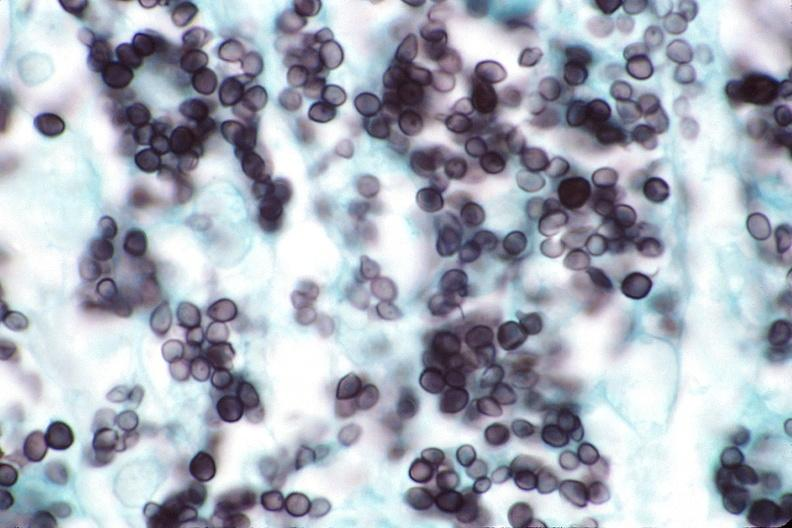what is present?
Answer the question using a single word or phrase. Respiratory 